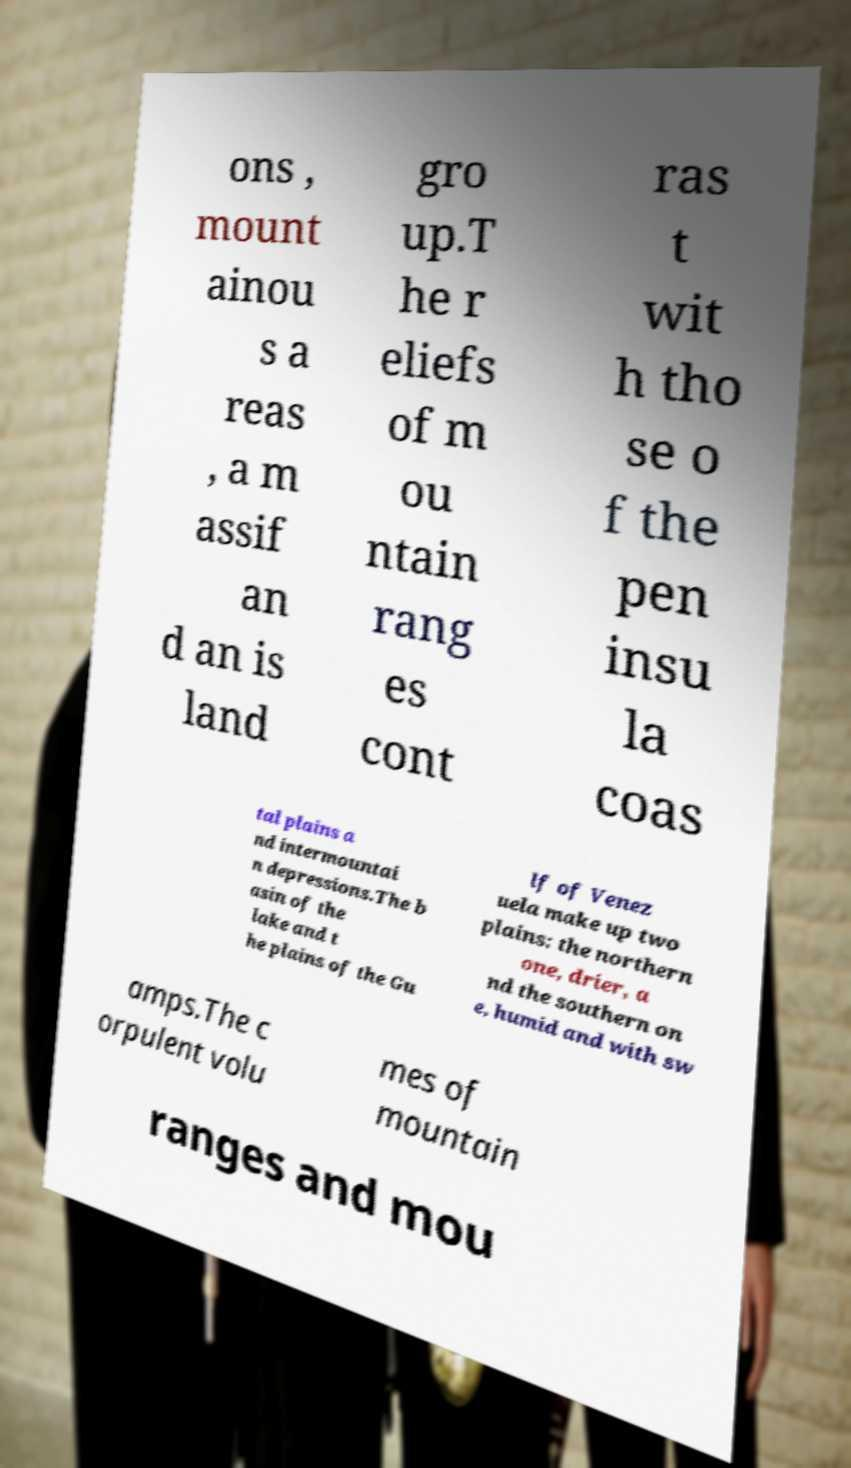There's text embedded in this image that I need extracted. Can you transcribe it verbatim? ons , mount ainou s a reas , a m assif an d an is land gro up.T he r eliefs of m ou ntain rang es cont ras t wit h tho se o f the pen insu la coas tal plains a nd intermountai n depressions.The b asin of the lake and t he plains of the Gu lf of Venez uela make up two plains: the northern one, drier, a nd the southern on e, humid and with sw amps.The c orpulent volu mes of mountain ranges and mou 